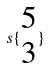<formula> <loc_0><loc_0><loc_500><loc_500>s \{ \begin{matrix} 5 \\ 3 \end{matrix} \}</formula> 